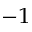Convert formula to latex. <formula><loc_0><loc_0><loc_500><loc_500>^ { - 1 }</formula> 